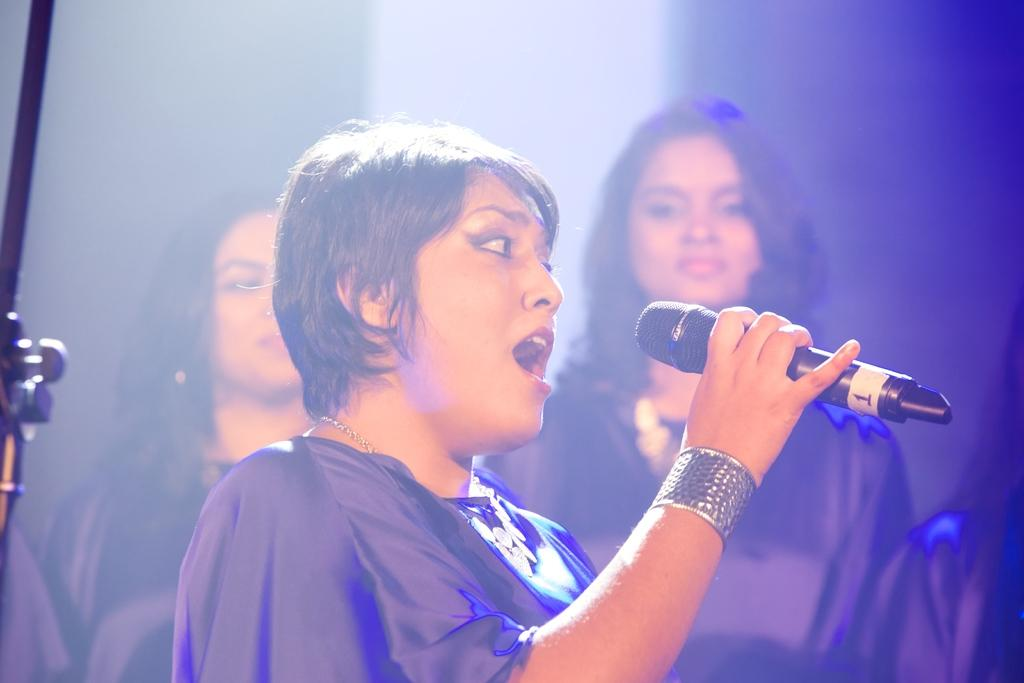How many women are in the image? There are three women in the image. What is one of the women doing in the image? One of the women is holding a microphone. What is the woman with the microphone doing? The woman with the microphone is singing. Can you describe the appearance of the woman with the microphone? The woman with the microphone has short hair and is wearing a bracelet. What color are the eyes of the expert in the image? There is no expert present in the image, and therefore no eye color can be determined. 